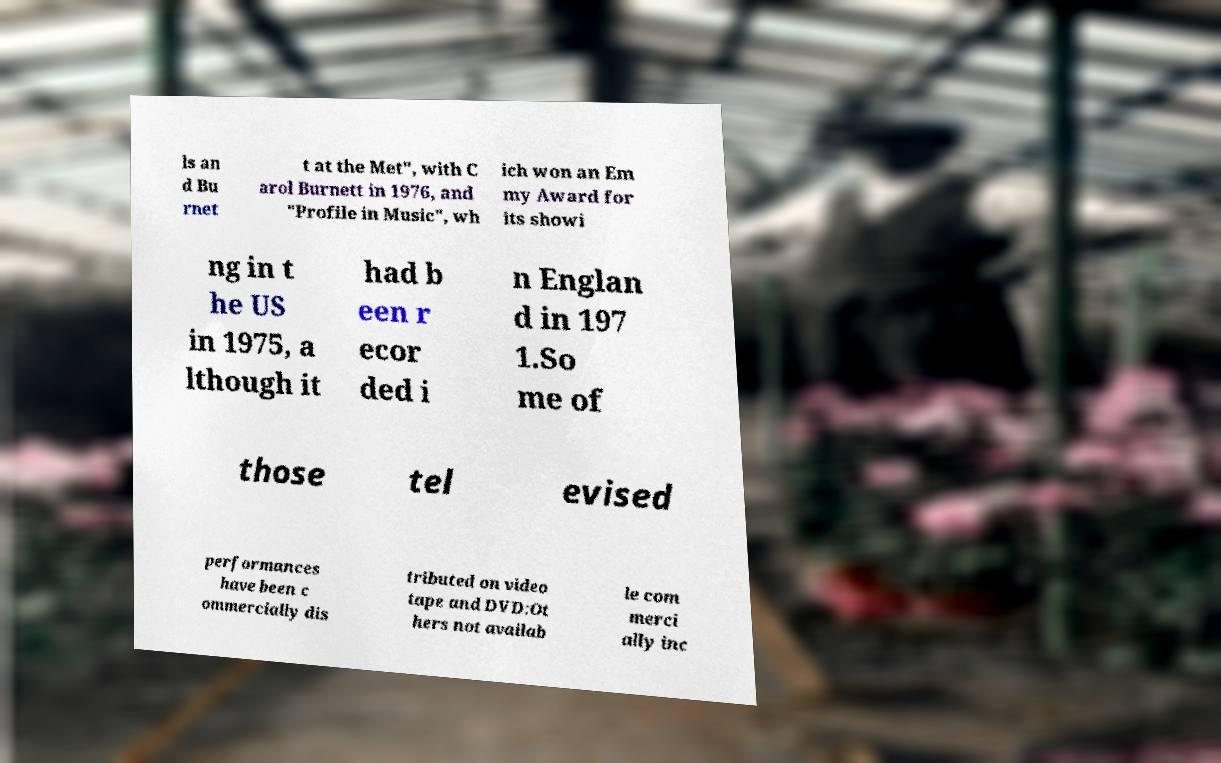Please identify and transcribe the text found in this image. ls an d Bu rnet t at the Met", with C arol Burnett in 1976, and "Profile in Music", wh ich won an Em my Award for its showi ng in t he US in 1975, a lthough it had b een r ecor ded i n Englan d in 197 1.So me of those tel evised performances have been c ommercially dis tributed on video tape and DVD:Ot hers not availab le com merci ally inc 